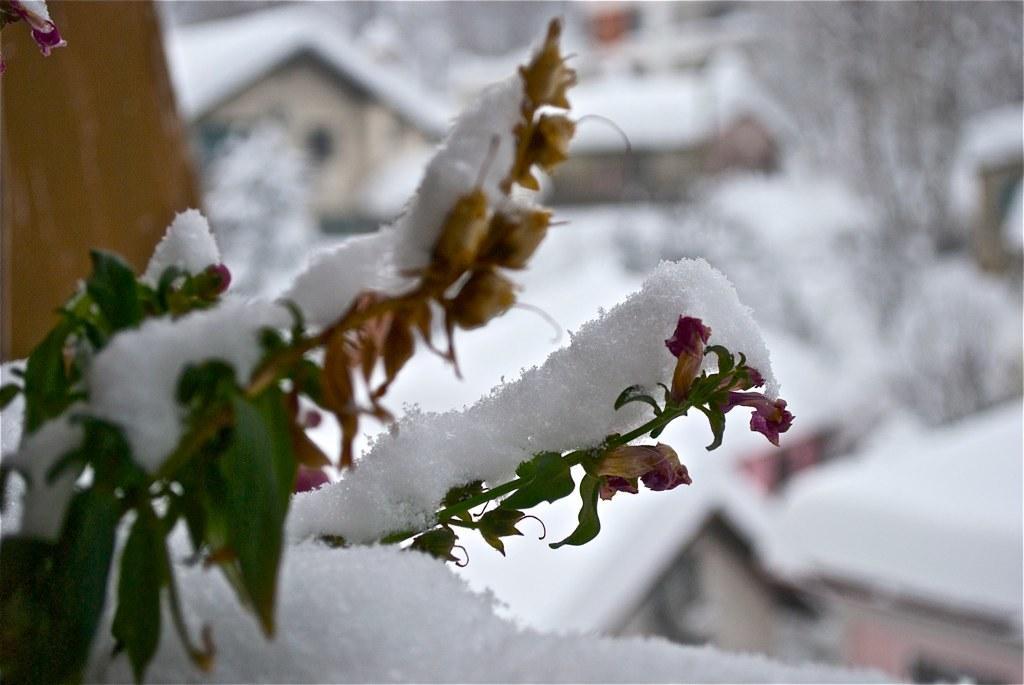In one or two sentences, can you explain what this image depicts? In this image there is a plant, that plant is covered with snow and the background is blurred. 